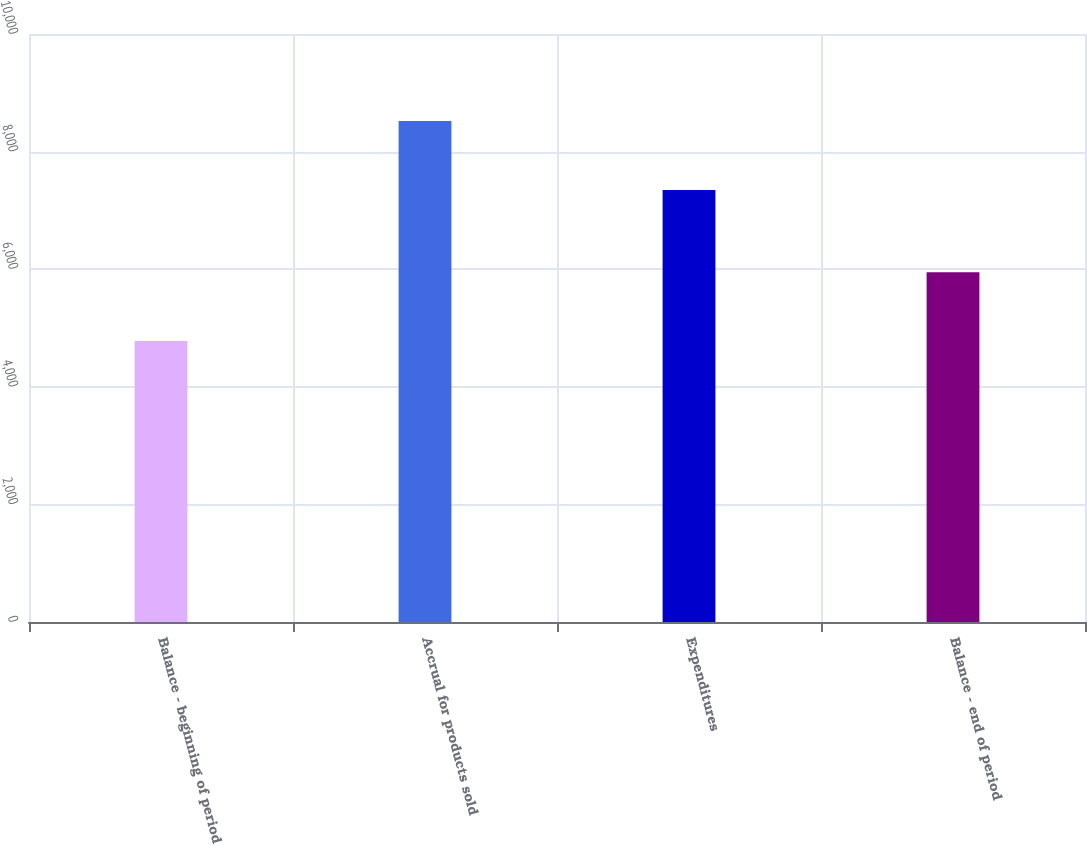<chart> <loc_0><loc_0><loc_500><loc_500><bar_chart><fcel>Balance - beginning of period<fcel>Accrual for products sold<fcel>Expenditures<fcel>Balance - end of period<nl><fcel>4777<fcel>8520<fcel>7348<fcel>5949<nl></chart> 